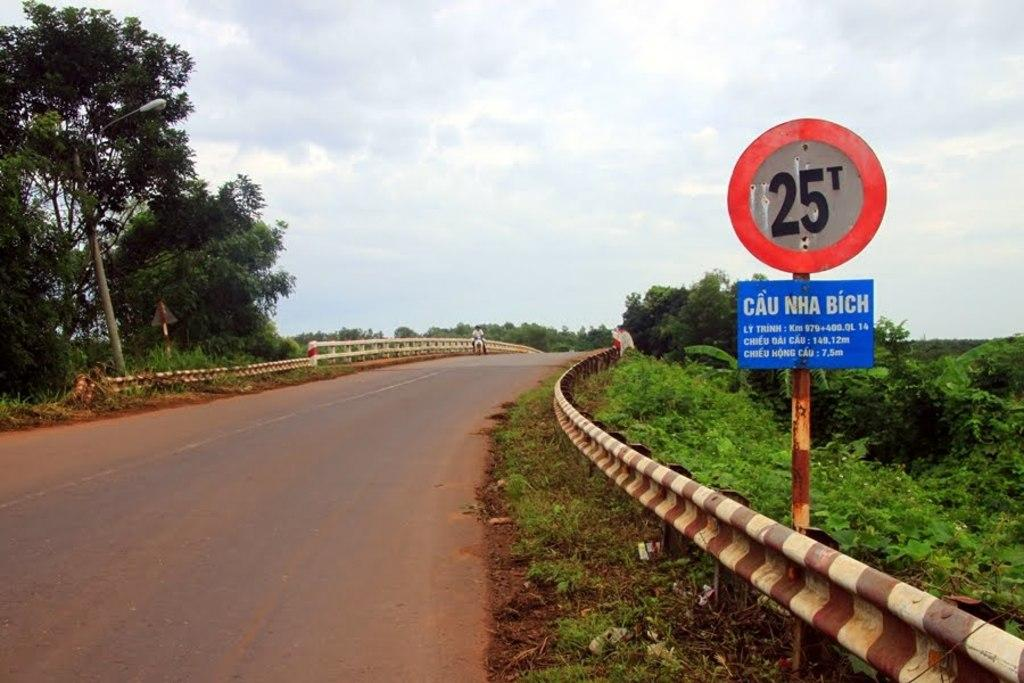<image>
Share a concise interpretation of the image provided. 25t Sign that says CAU NHA BICH on the side of the road. 